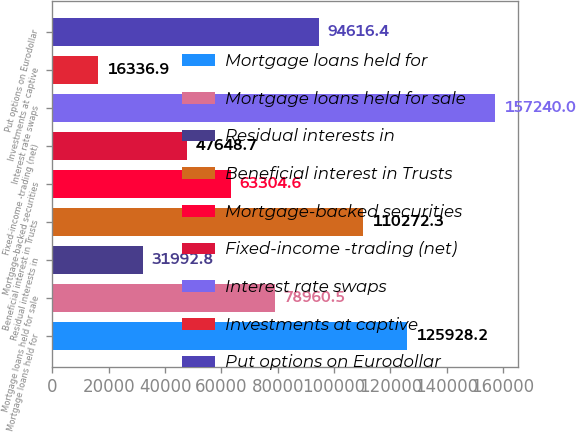Convert chart. <chart><loc_0><loc_0><loc_500><loc_500><bar_chart><fcel>Mortgage loans held for<fcel>Mortgage loans held for sale<fcel>Residual interests in<fcel>Beneficial interest in Trusts<fcel>Mortgage-backed securities<fcel>Fixed-income -trading (net)<fcel>Interest rate swaps<fcel>Investments at captive<fcel>Put options on Eurodollar<nl><fcel>125928<fcel>78960.5<fcel>31992.8<fcel>110272<fcel>63304.6<fcel>47648.7<fcel>157240<fcel>16336.9<fcel>94616.4<nl></chart> 